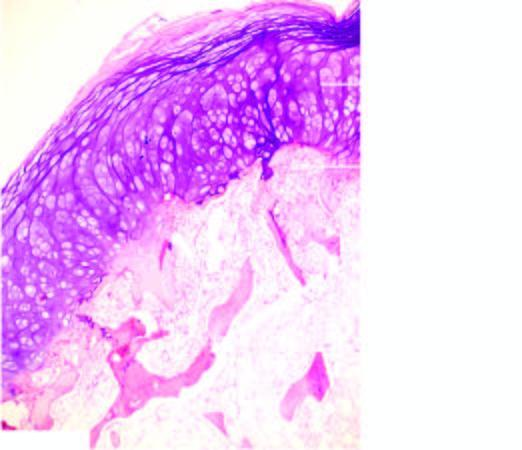what does the overlying cap show?
Answer the question using a single word or phrase. Mature cartilage cells covering the underlying mature lamellar bone containing marrow spaces 